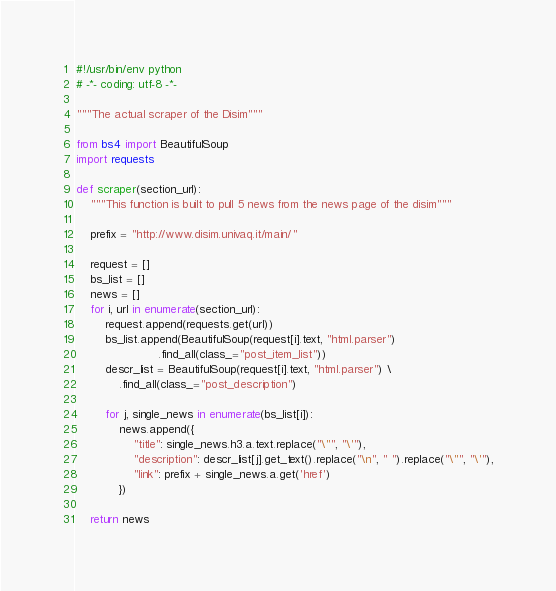Convert code to text. <code><loc_0><loc_0><loc_500><loc_500><_Python_>#!/usr/bin/env python
# -*- coding: utf-8 -*-

"""The actual scraper of the Disim"""

from bs4 import BeautifulSoup
import requests

def scraper(section_url):
    """This function is built to pull 5 news from the news page of the disim"""

    prefix = "http://www.disim.univaq.it/main/"

    request = []
    bs_list = []
    news = []
    for i, url in enumerate(section_url):
        request.append(requests.get(url))
        bs_list.append(BeautifulSoup(request[i].text, "html.parser")
                       .find_all(class_="post_item_list"))
        descr_list = BeautifulSoup(request[i].text, "html.parser") \
            .find_all(class_="post_description")

        for j, single_news in enumerate(bs_list[i]):
            news.append({
                "title": single_news.h3.a.text.replace("\"", "\'"),
                "description": descr_list[j].get_text().replace("\n", " ").replace("\"", "\'"),
                "link": prefix + single_news.a.get('href')
            })

    return news
</code> 